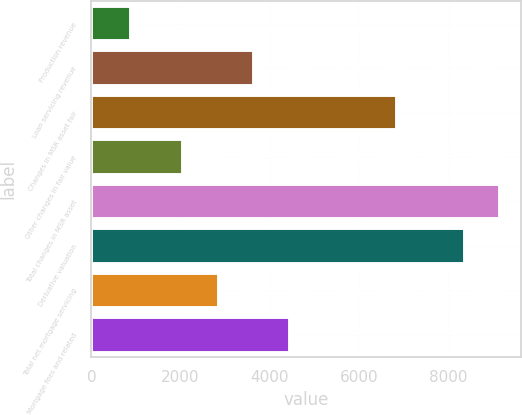Convert chart to OTSL. <chart><loc_0><loc_0><loc_500><loc_500><bar_chart><fcel>Production revenue<fcel>Loan servicing revenue<fcel>Changes in MSR asset fair<fcel>Other changes in fair value<fcel>Total changes in MSR asset<fcel>Derivative valuation<fcel>Total net mortgage servicing<fcel>Mortgage fees and related<nl><fcel>898<fcel>3652.6<fcel>6849<fcel>2052<fcel>9166.3<fcel>8366<fcel>2852.3<fcel>4452.9<nl></chart> 